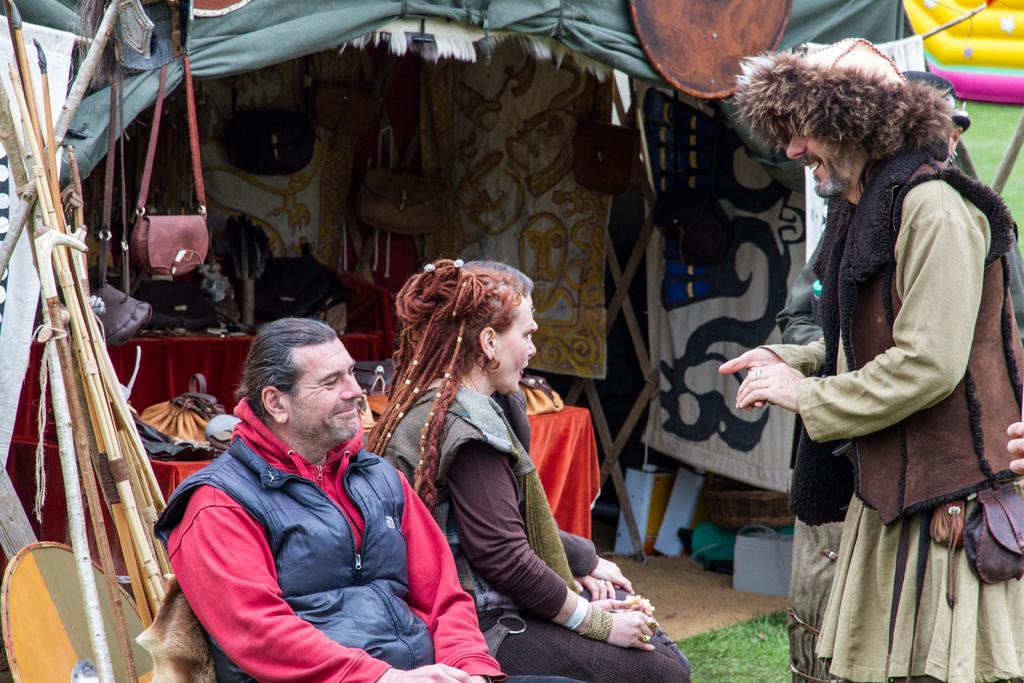How would you summarize this image in a sentence or two? In this image I can see three persons. In front the person is wearing black and red color dress. In the background I can see few wooden sticks, few bags and I can also see few banners in multi color. 